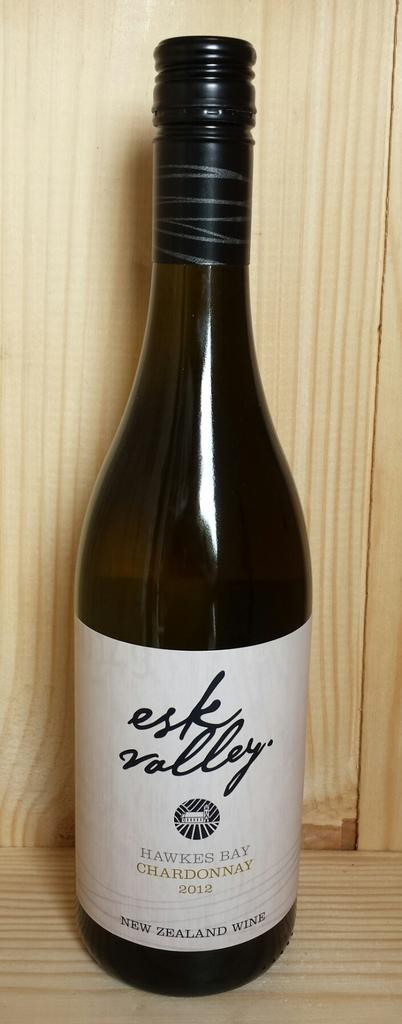Provide a one-sentence caption for the provided image. Esk Valley Hawkesbay Chardonnay 2012 wine from Newzealand in dark color bottle. 